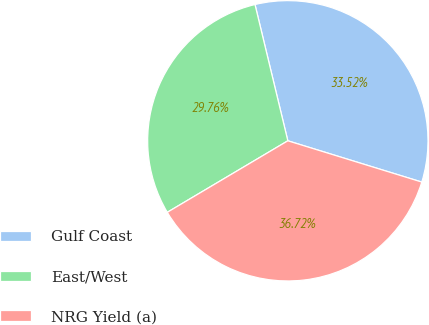Convert chart. <chart><loc_0><loc_0><loc_500><loc_500><pie_chart><fcel>Gulf Coast<fcel>East/West<fcel>NRG Yield (a)<nl><fcel>33.52%<fcel>29.76%<fcel>36.72%<nl></chart> 